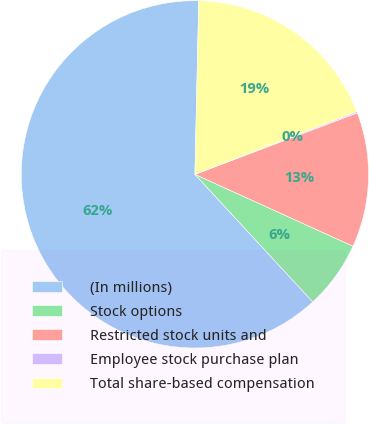Convert chart to OTSL. <chart><loc_0><loc_0><loc_500><loc_500><pie_chart><fcel>(In millions)<fcel>Stock options<fcel>Restricted stock units and<fcel>Employee stock purchase plan<fcel>Total share-based compensation<nl><fcel>62.22%<fcel>6.34%<fcel>12.55%<fcel>0.13%<fcel>18.76%<nl></chart> 